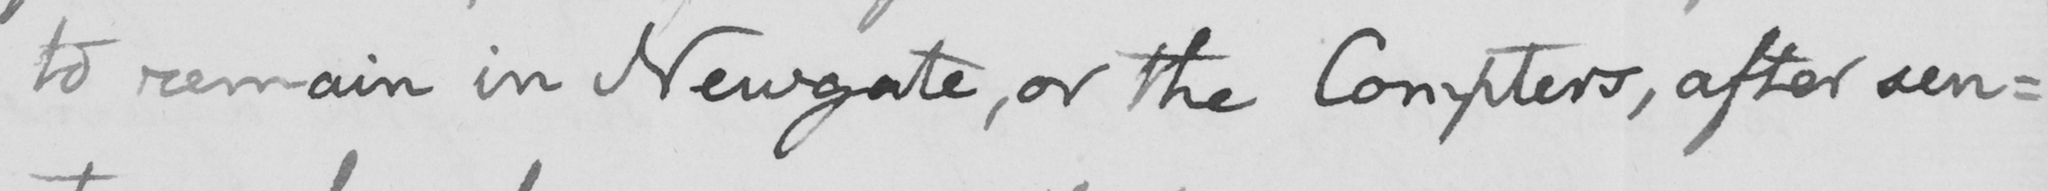Can you read and transcribe this handwriting? to remain in Newgate, or the Compters, after sen: 